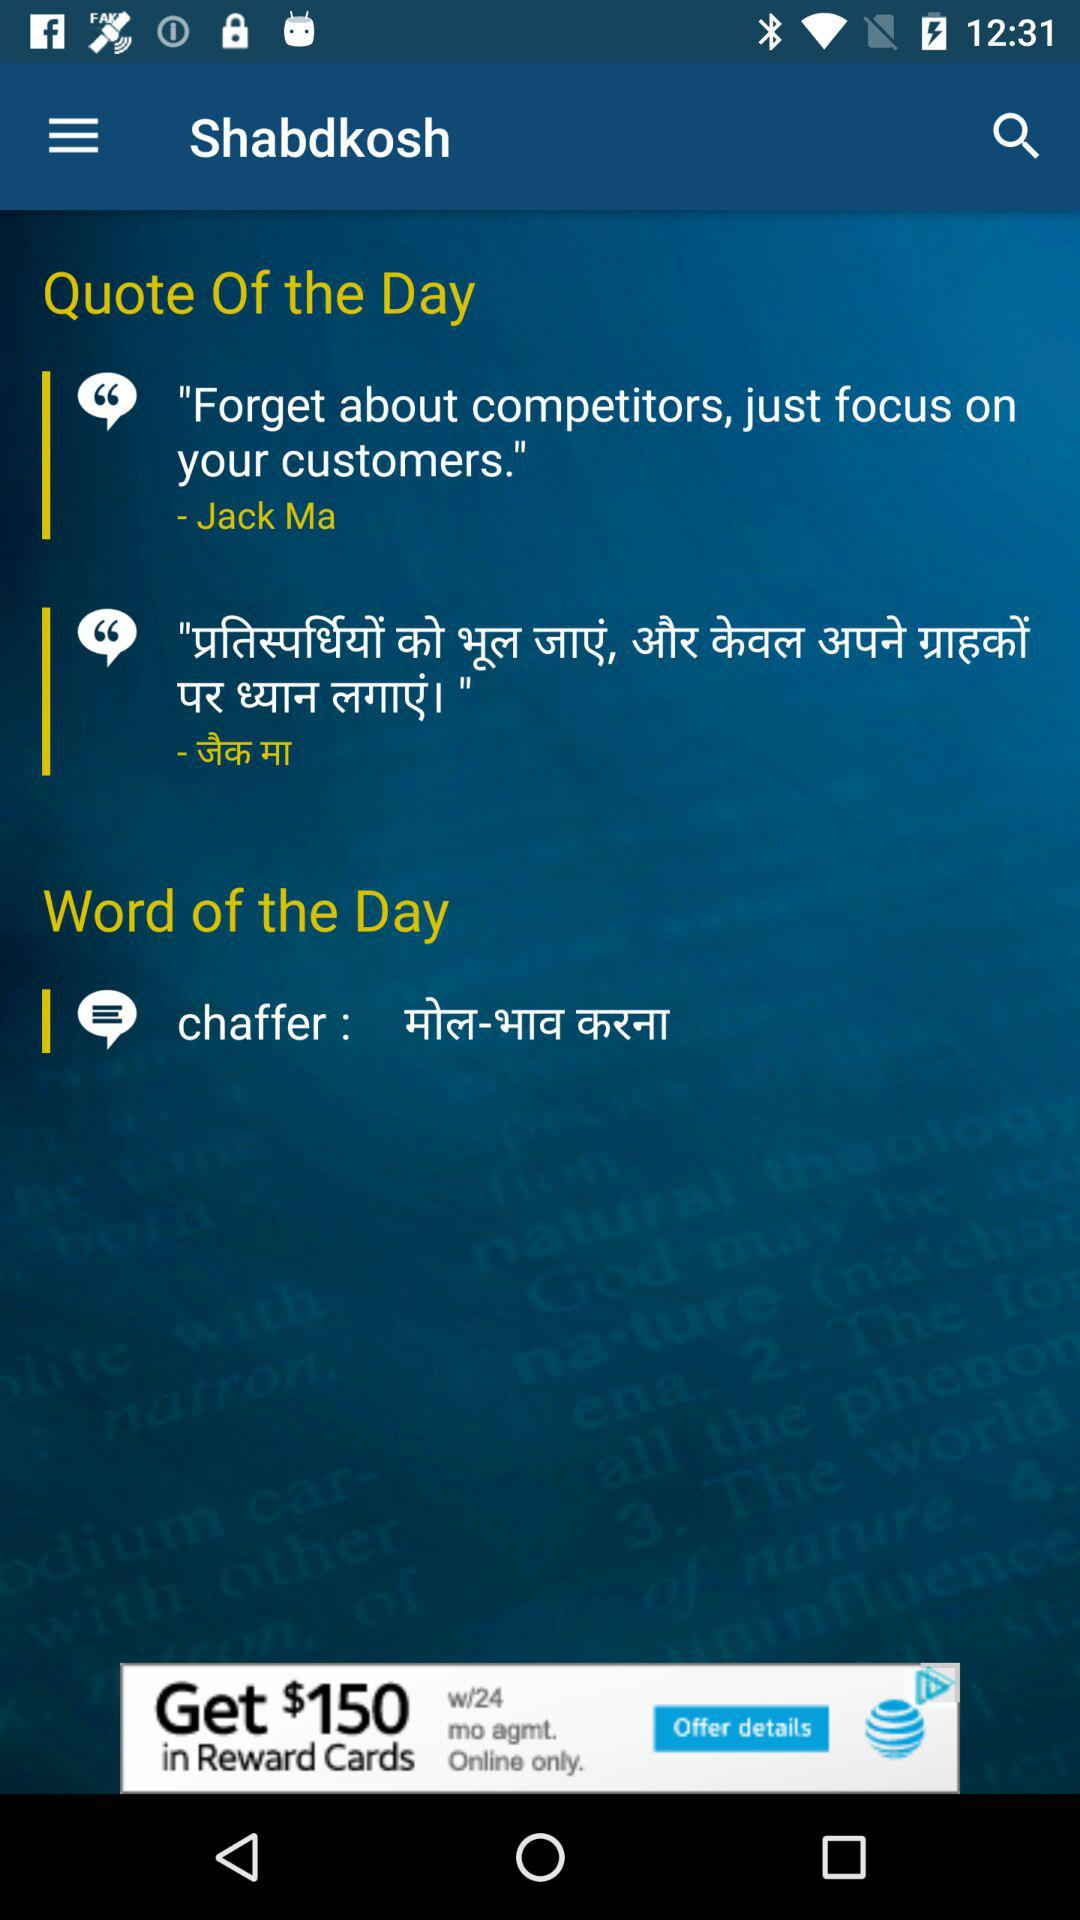Who wrote the quote? The one who wrote the quote is "Jack Ma". 